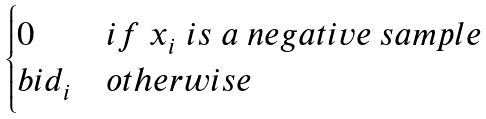Convert formula to latex. <formula><loc_0><loc_0><loc_500><loc_500>\begin{cases} 0 & i f \ x _ { i } \ i s \ a \ n e g a t i v e \ s a m p l e \\ b i d _ { i } & o t h e r w i s e \end{cases}</formula> 